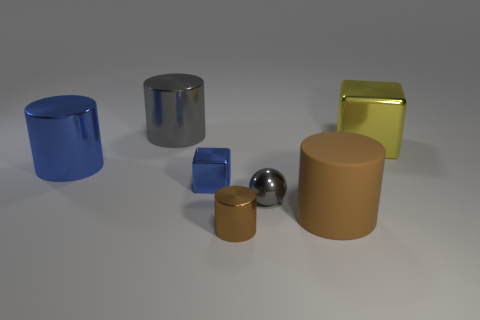There is a thing that is the same color as the small cylinder; what is it made of?
Make the answer very short. Rubber. What is the shape of the object that is both behind the small shiny cube and to the right of the large gray metallic cylinder?
Provide a succinct answer. Cube. What material is the brown object behind the shiny cylinder in front of the tiny blue cube?
Make the answer very short. Rubber. Is the number of tiny brown cylinders greater than the number of small matte cylinders?
Your answer should be very brief. Yes. Do the big rubber object and the small cylinder have the same color?
Provide a succinct answer. Yes. There is a blue object that is the same size as the brown shiny cylinder; what material is it?
Ensure brevity in your answer.  Metal. Does the large yellow cube have the same material as the big gray cylinder?
Make the answer very short. Yes. What number of brown things have the same material as the tiny brown cylinder?
Ensure brevity in your answer.  0. What number of objects are either big cylinders that are left of the blue cube or objects that are in front of the large yellow metallic cube?
Keep it short and to the point. 6. Are there more metal cylinders that are in front of the metallic sphere than big matte cylinders that are left of the big blue object?
Offer a very short reply. Yes. 